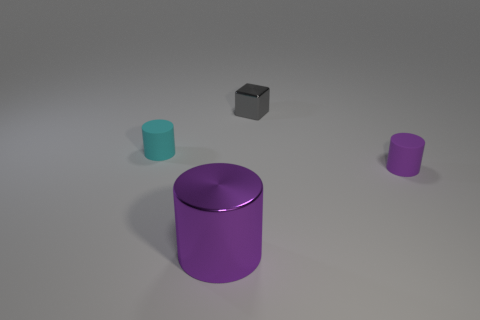How many purple cylinders must be subtracted to get 1 purple cylinders? 1 Subtract all tiny matte cylinders. How many cylinders are left? 1 Subtract all red spheres. How many purple cylinders are left? 2 Add 3 metal cubes. How many objects exist? 7 Subtract all cyan cylinders. How many cylinders are left? 2 Subtract all cylinders. How many objects are left? 1 Subtract all purple cubes. Subtract all red balls. How many cubes are left? 1 Subtract all purple rubber things. Subtract all big purple objects. How many objects are left? 2 Add 4 big purple objects. How many big purple objects are left? 5 Add 2 large red matte things. How many large red matte things exist? 2 